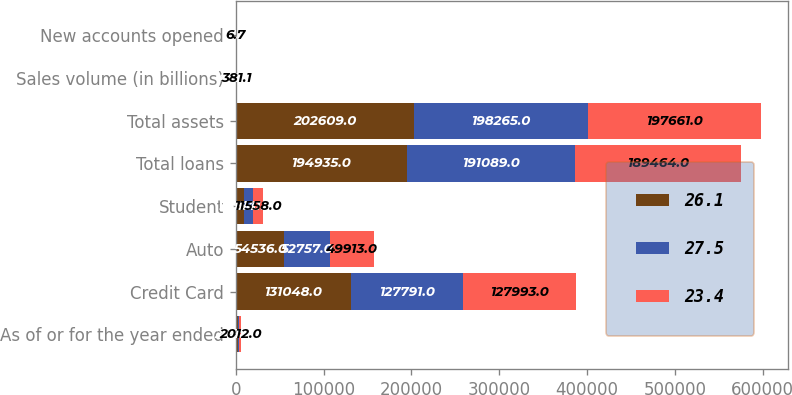<chart> <loc_0><loc_0><loc_500><loc_500><stacked_bar_chart><ecel><fcel>As of or for the year ended<fcel>Credit Card<fcel>Auto<fcel>Student<fcel>Total loans<fcel>Total assets<fcel>Sales volume (in billions)<fcel>New accounts opened<nl><fcel>26.1<fcel>2014<fcel>131048<fcel>54536<fcel>9351<fcel>194935<fcel>202609<fcel>465.6<fcel>8.8<nl><fcel>27.5<fcel>2013<fcel>127791<fcel>52757<fcel>10541<fcel>191089<fcel>198265<fcel>419.5<fcel>7.3<nl><fcel>23.4<fcel>2012<fcel>127993<fcel>49913<fcel>11558<fcel>189464<fcel>197661<fcel>381.1<fcel>6.7<nl></chart> 